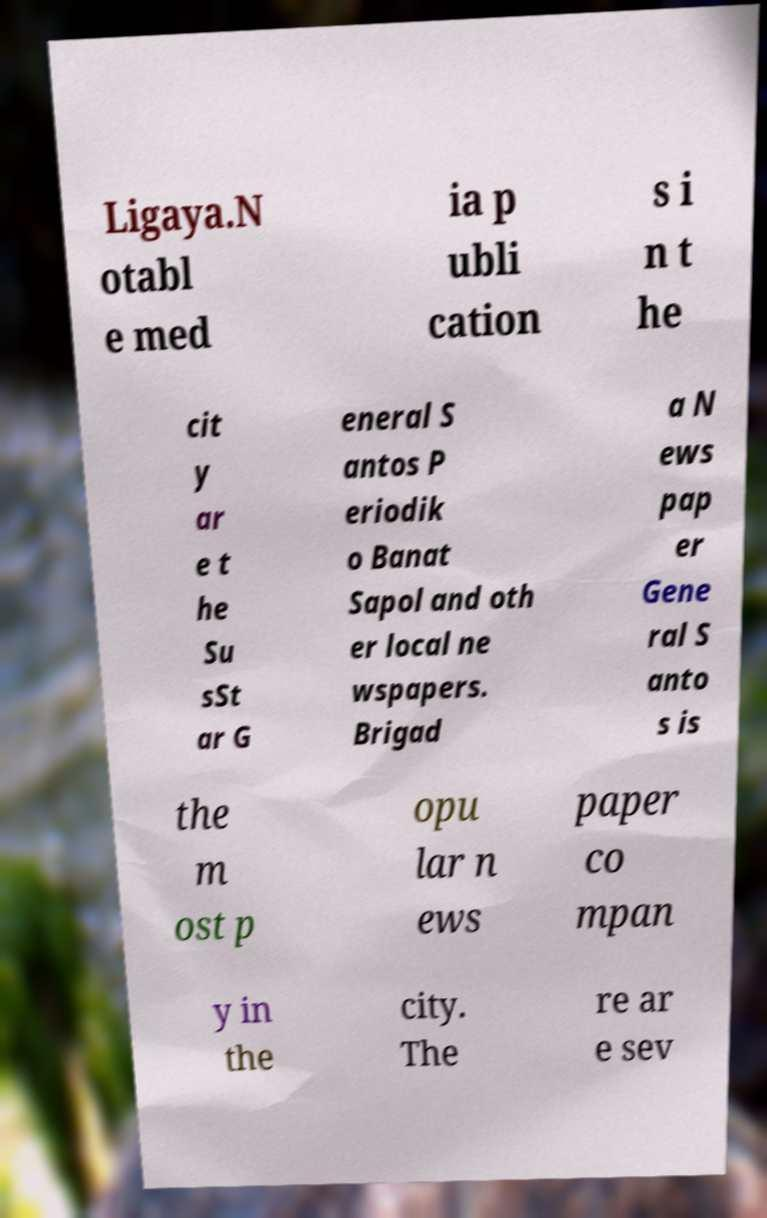Can you read and provide the text displayed in the image?This photo seems to have some interesting text. Can you extract and type it out for me? Ligaya.N otabl e med ia p ubli cation s i n t he cit y ar e t he Su sSt ar G eneral S antos P eriodik o Banat Sapol and oth er local ne wspapers. Brigad a N ews pap er Gene ral S anto s is the m ost p opu lar n ews paper co mpan y in the city. The re ar e sev 